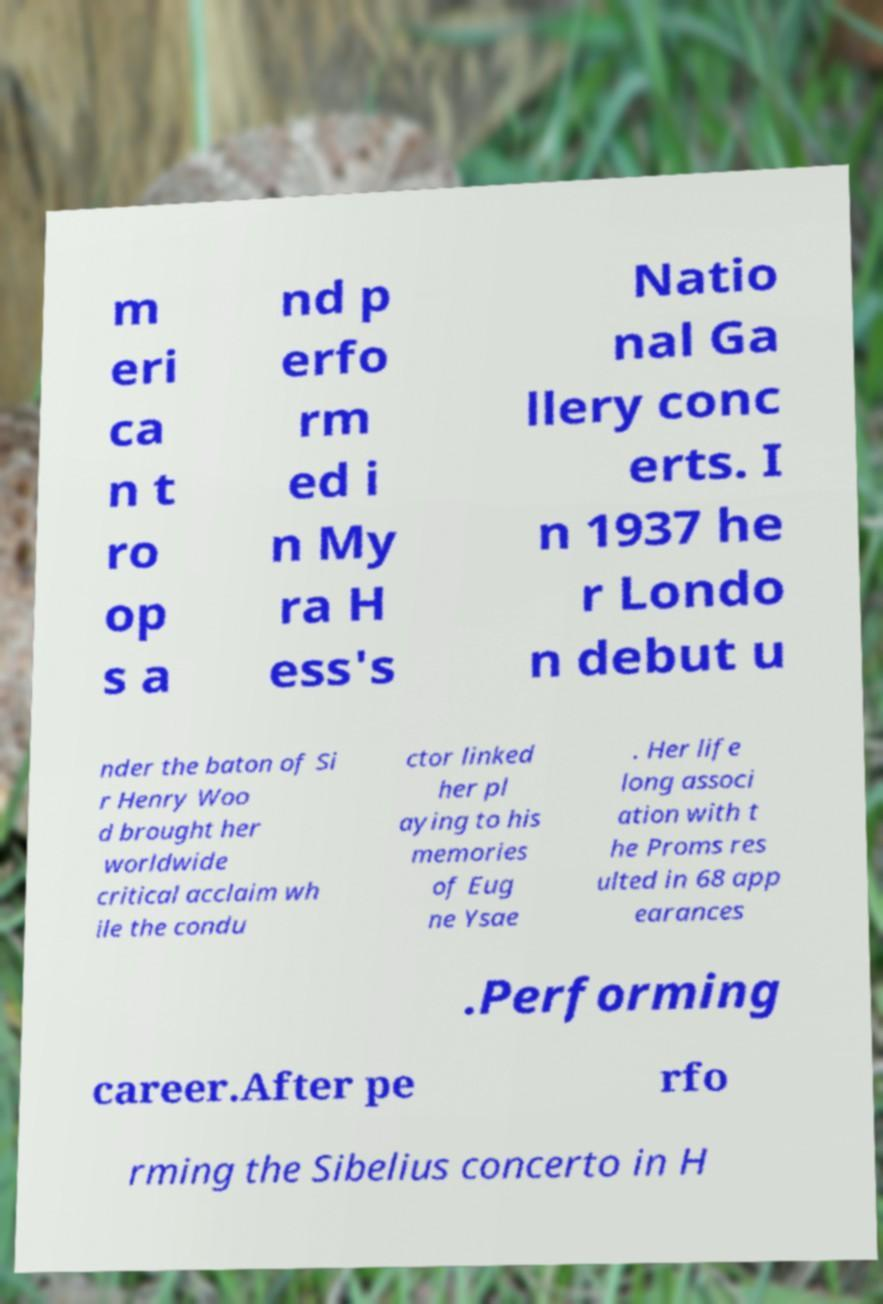I need the written content from this picture converted into text. Can you do that? m eri ca n t ro op s a nd p erfo rm ed i n My ra H ess's Natio nal Ga llery conc erts. I n 1937 he r Londo n debut u nder the baton of Si r Henry Woo d brought her worldwide critical acclaim wh ile the condu ctor linked her pl aying to his memories of Eug ne Ysae . Her life long associ ation with t he Proms res ulted in 68 app earances .Performing career.After pe rfo rming the Sibelius concerto in H 